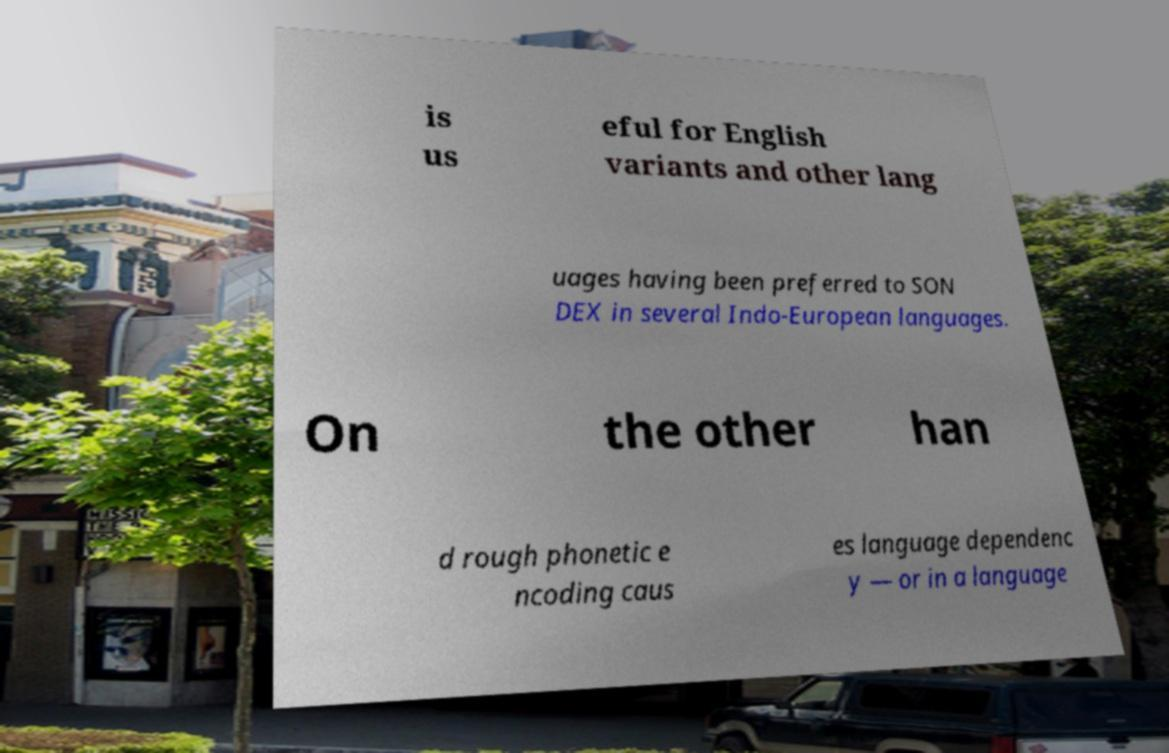Please read and relay the text visible in this image. What does it say? is us eful for English variants and other lang uages having been preferred to SON DEX in several Indo-European languages. On the other han d rough phonetic e ncoding caus es language dependenc y — or in a language 